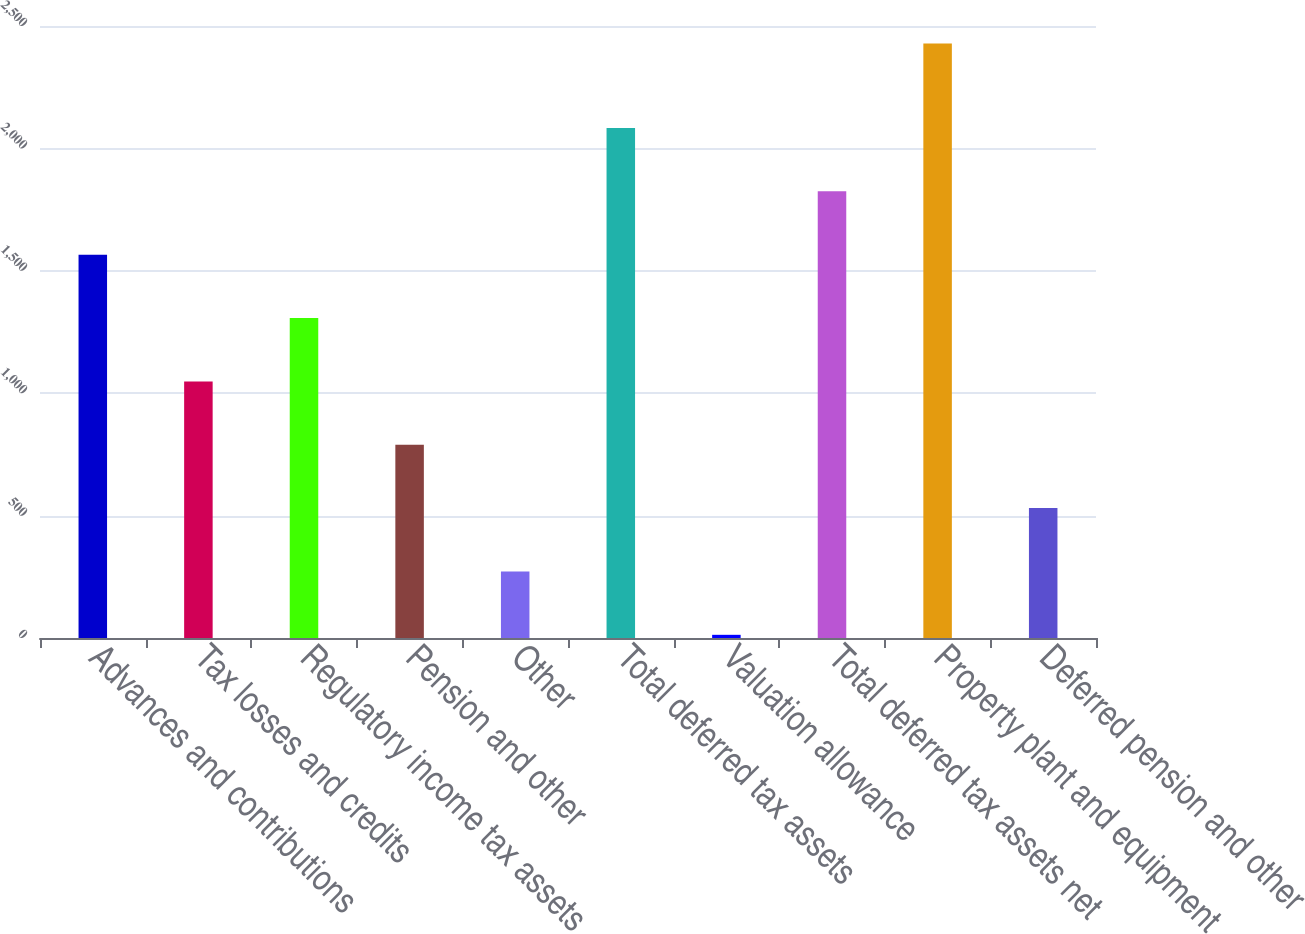<chart> <loc_0><loc_0><loc_500><loc_500><bar_chart><fcel>Advances and contributions<fcel>Tax losses and credits<fcel>Regulatory income tax assets<fcel>Pension and other<fcel>Other<fcel>Total deferred tax assets<fcel>Valuation allowance<fcel>Total deferred tax assets net<fcel>Property plant and equipment<fcel>Deferred pension and other<nl><fcel>1565.8<fcel>1048.2<fcel>1307<fcel>789.4<fcel>271.8<fcel>2083.4<fcel>13<fcel>1824.6<fcel>2429<fcel>530.6<nl></chart> 